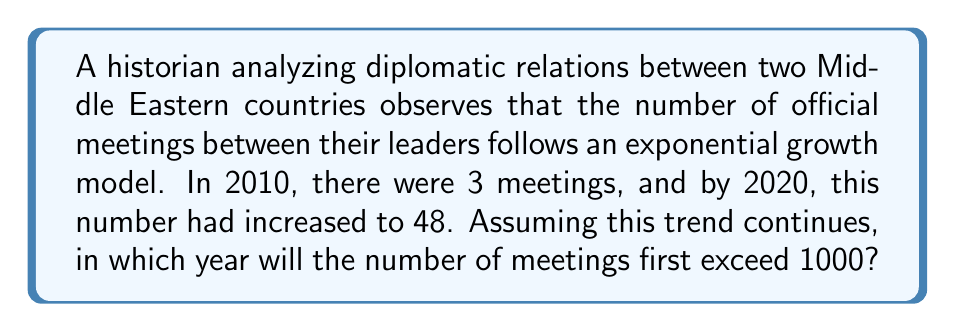Help me with this question. Let's approach this step-by-step using logarithms:

1) Let's define our exponential function:
   $N(t) = 3 \cdot a^t$
   where $N$ is the number of meetings, $t$ is the number of years since 2010, and $a$ is the annual growth factor.

2) We know that after 10 years (in 2020), $N(10) = 48$. Let's use this to find $a$:
   $48 = 3 \cdot a^{10}$

3) Divide both sides by 3:
   $16 = a^{10}$

4) Take the 10th root of both sides:
   $a = \sqrt[10]{16} = 16^{\frac{1}{10}} \approx 1.3335$

5) Now, we want to find when $N(t) > 1000$:
   $3 \cdot (1.3335)^t > 1000$

6) Divide both sides by 3:
   $(1.3335)^t > 333.33$

7) Take the logarithm of both sides:
   $t \cdot \log(1.3335) > \log(333.33)$

8) Solve for $t$:
   $t > \frac{\log(333.33)}{\log(1.3335)} \approx 21.95$

9) Since $t$ represents years since 2010, we add 22 (rounding up) to 2010:
   2010 + 22 = 2032

Thus, the number of meetings will first exceed 1000 in 2032.
Answer: 2032 